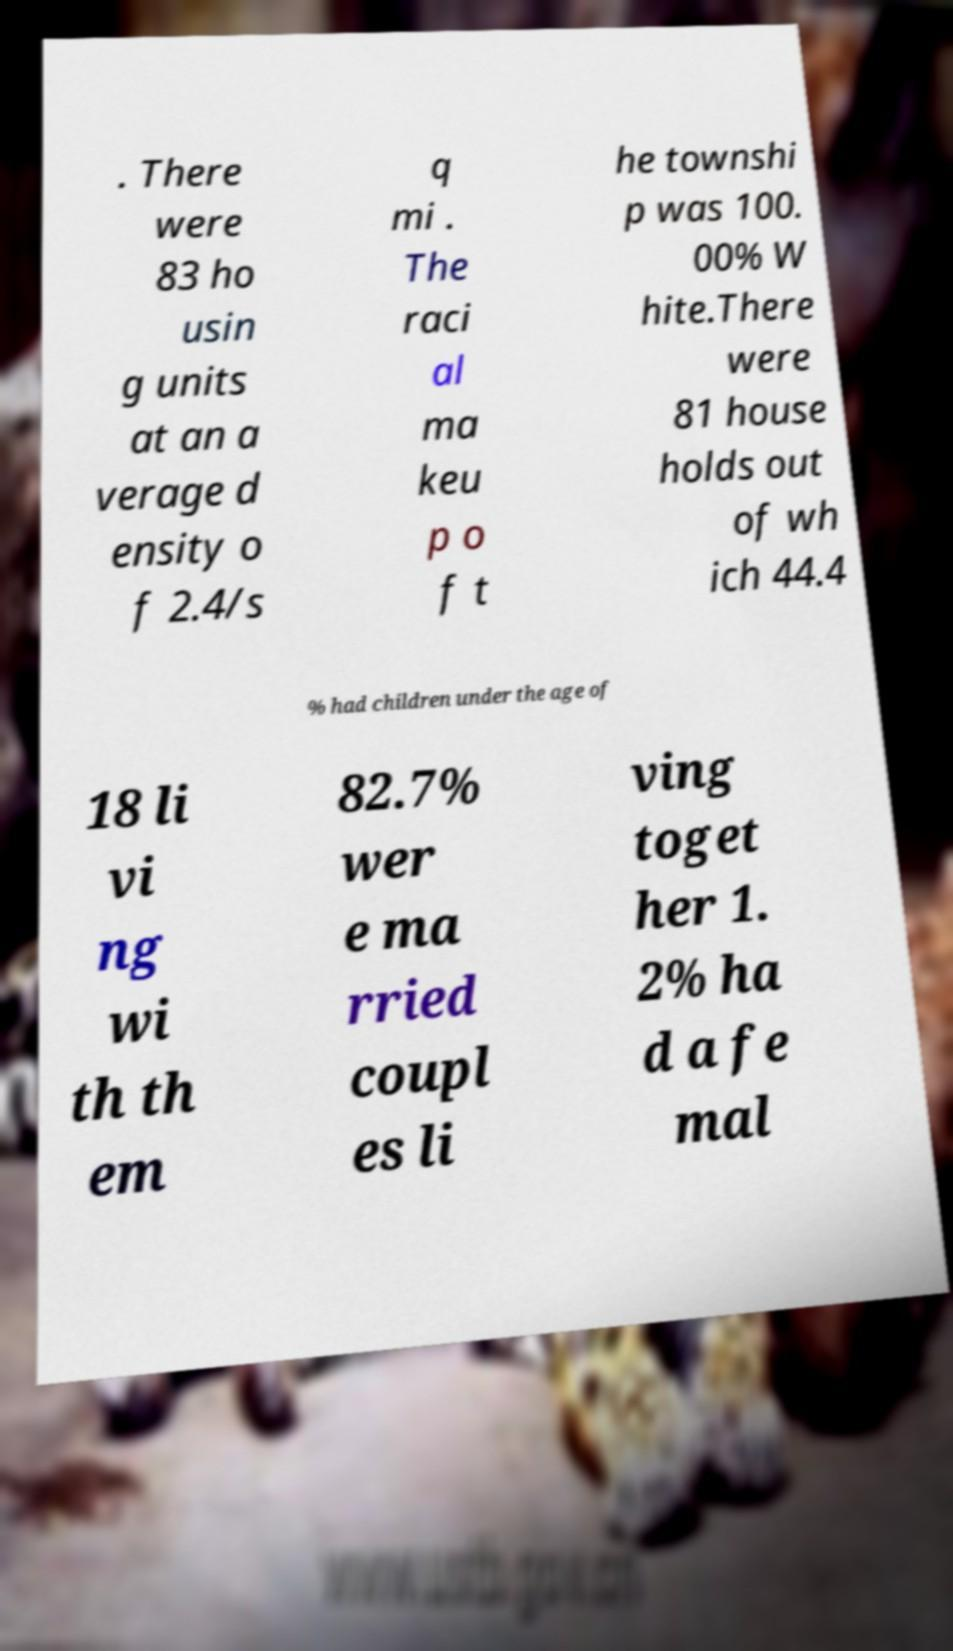Could you assist in decoding the text presented in this image and type it out clearly? . There were 83 ho usin g units at an a verage d ensity o f 2.4/s q mi . The raci al ma keu p o f t he townshi p was 100. 00% W hite.There were 81 house holds out of wh ich 44.4 % had children under the age of 18 li vi ng wi th th em 82.7% wer e ma rried coupl es li ving toget her 1. 2% ha d a fe mal 